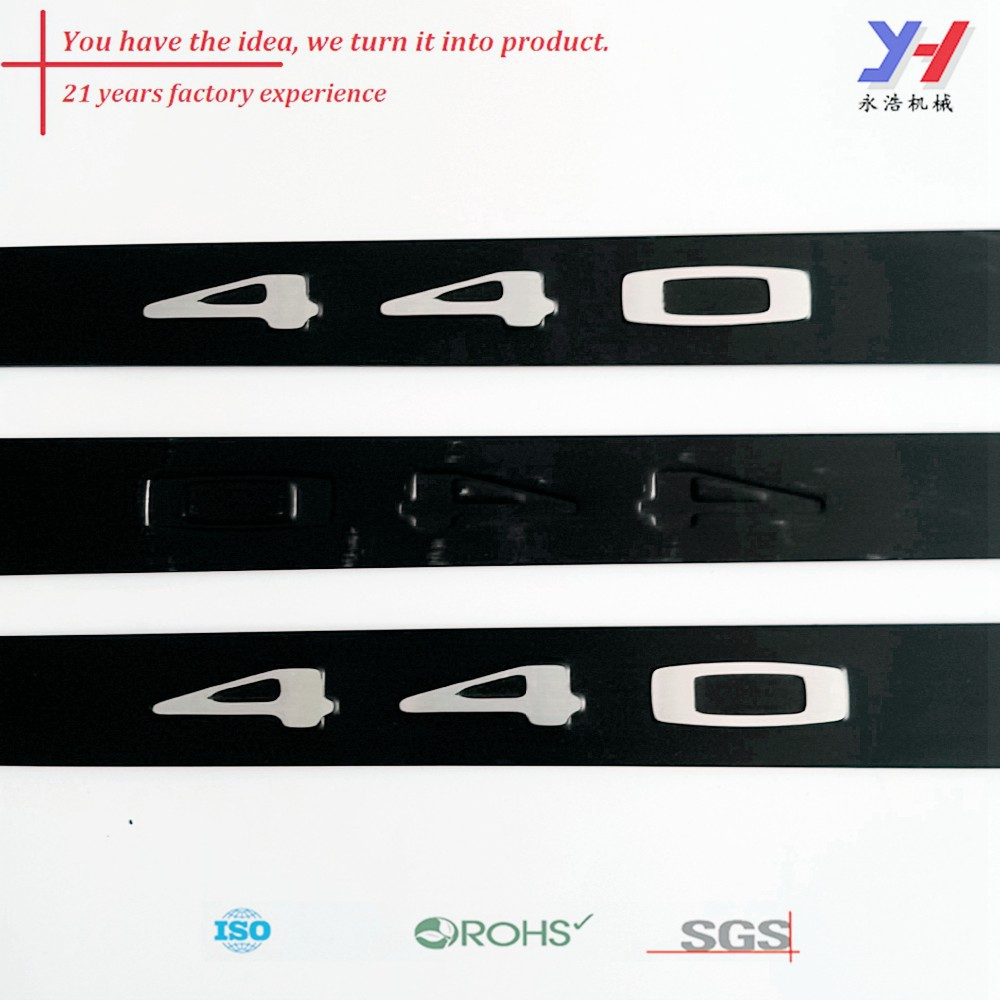Given the emphasis on '21 years factory experience,' what are potential advantages for customers working with this company? Given the emphasis on '21 years factory experience,' potential advantages for customers working with this company include a wealth of accumulated knowledge and expertise, ensuring high-quality products. Customers can expect reliability due to the company's long-standing presence in the industry, which usually indicates stability and trustworthiness. Additionally, experience often translates into efficient production processes, innovative solutions, and the ability to effectively navigate industry challenges, all of which can result in superior customer satisfaction and value. Can you succinctly highlight the main benefits of the company's 21 years of experience? The main benefits of the company’s 21 years of experience include high product quality, reliability, innovative solutions, and efficient production processes. 